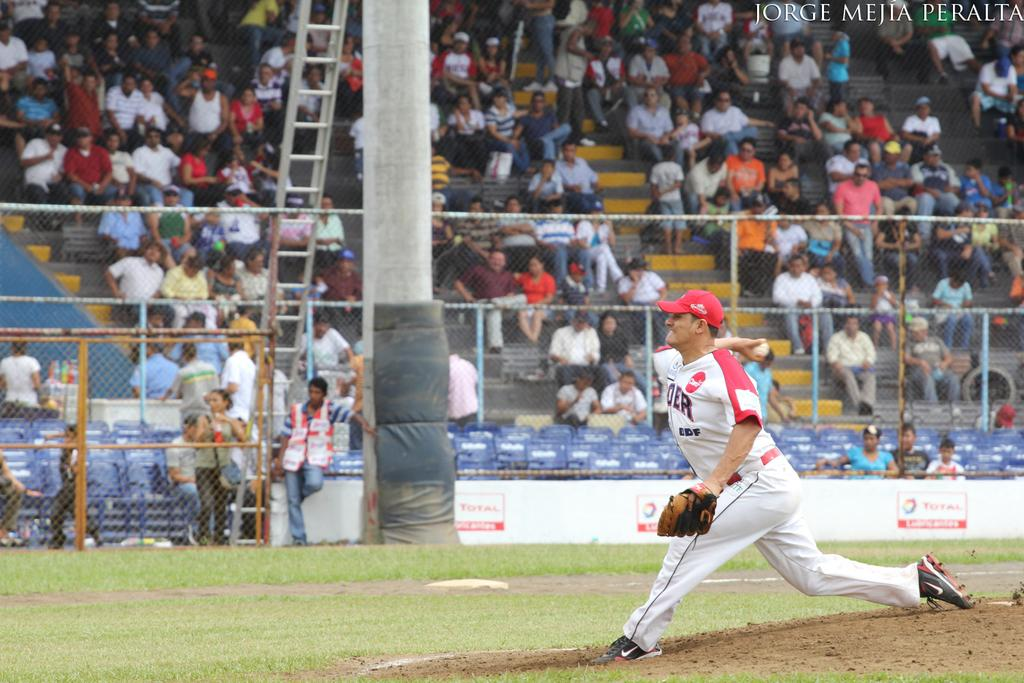<image>
Offer a succinct explanation of the picture presented. pitcher with letters OER on front of jersey getting ready to throw the ball 